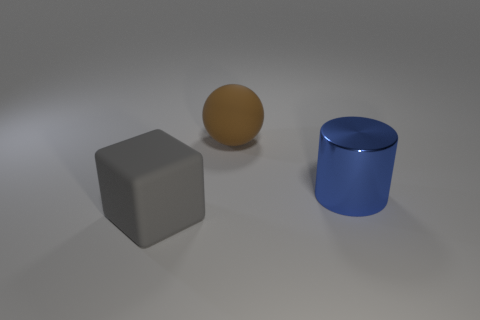Subtract all blocks. How many objects are left? 2 Subtract 1 blocks. How many blocks are left? 0 Subtract all brown cylinders. Subtract all brown cubes. How many cylinders are left? 1 Subtract all cyan blocks. How many gray cylinders are left? 0 Subtract all blue rubber blocks. Subtract all big metallic things. How many objects are left? 2 Add 3 big matte things. How many big matte things are left? 5 Add 3 green cubes. How many green cubes exist? 3 Add 1 spheres. How many objects exist? 4 Subtract 0 red cubes. How many objects are left? 3 